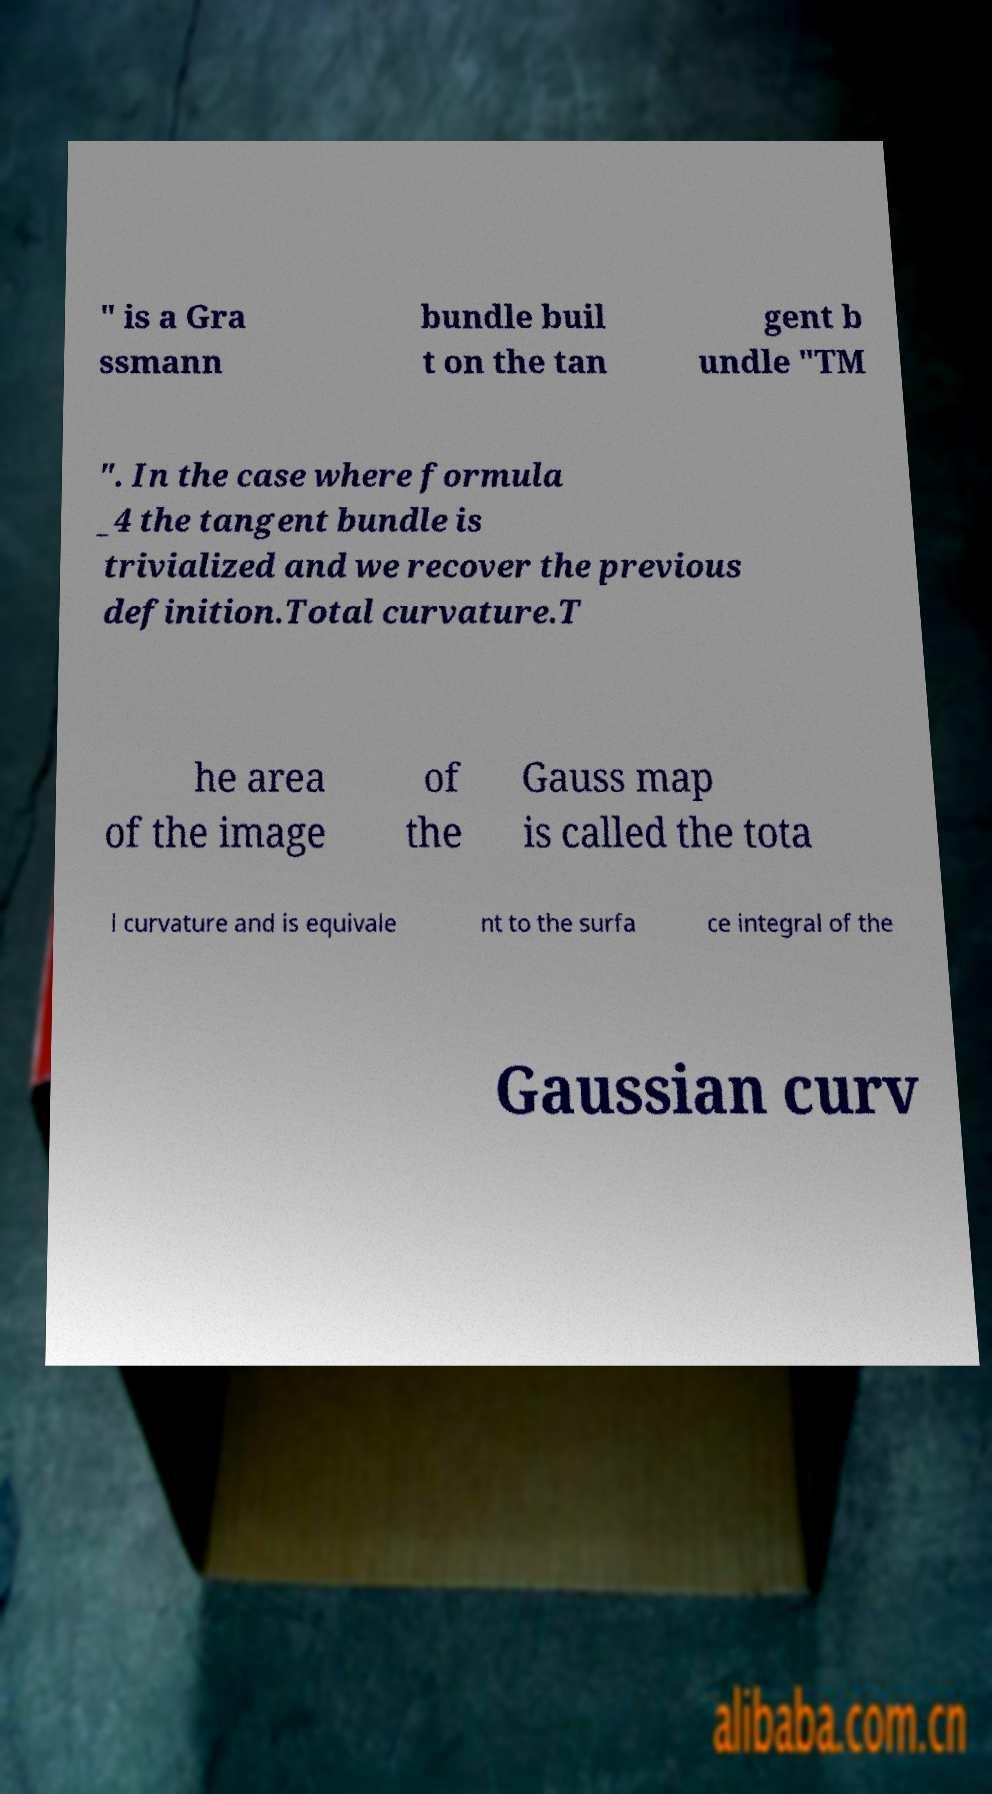Please read and relay the text visible in this image. What does it say? " is a Gra ssmann bundle buil t on the tan gent b undle "TM ". In the case where formula _4 the tangent bundle is trivialized and we recover the previous definition.Total curvature.T he area of the image of the Gauss map is called the tota l curvature and is equivale nt to the surfa ce integral of the Gaussian curv 